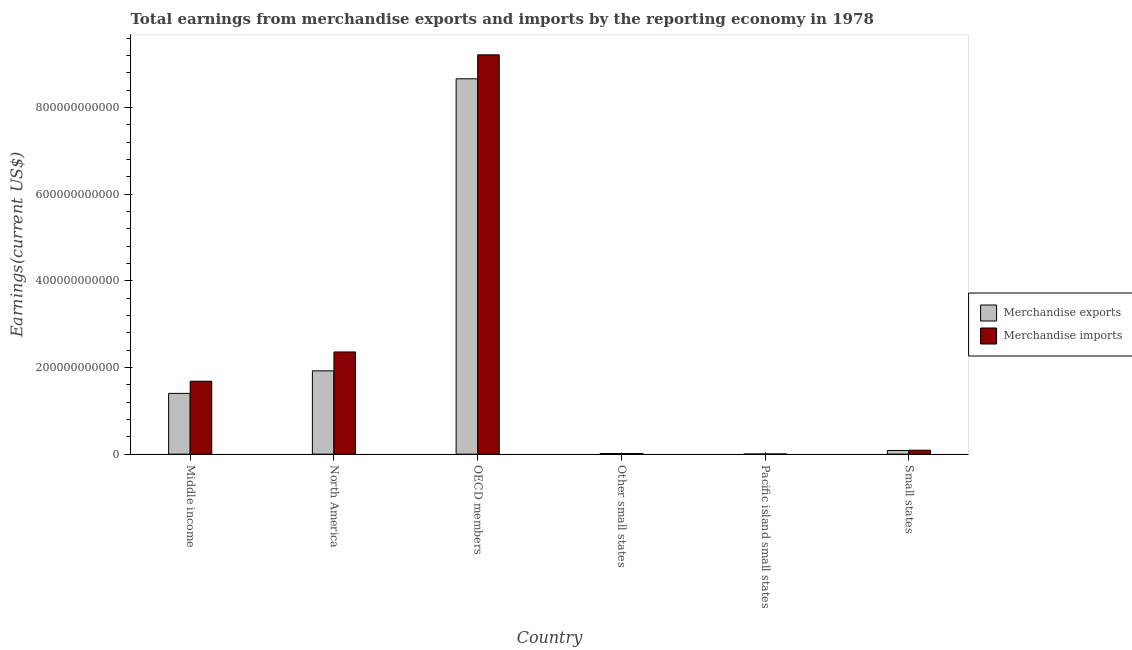How many different coloured bars are there?
Provide a short and direct response. 2. How many bars are there on the 3rd tick from the left?
Keep it short and to the point. 2. How many bars are there on the 6th tick from the right?
Your answer should be very brief. 2. What is the label of the 5th group of bars from the left?
Provide a short and direct response. Pacific island small states. In how many cases, is the number of bars for a given country not equal to the number of legend labels?
Give a very brief answer. 0. What is the earnings from merchandise imports in OECD members?
Your response must be concise. 9.21e+11. Across all countries, what is the maximum earnings from merchandise imports?
Keep it short and to the point. 9.21e+11. Across all countries, what is the minimum earnings from merchandise imports?
Your response must be concise. 4.48e+08. In which country was the earnings from merchandise imports minimum?
Provide a succinct answer. Pacific island small states. What is the total earnings from merchandise exports in the graph?
Your answer should be compact. 1.21e+12. What is the difference between the earnings from merchandise exports in North America and that in Small states?
Offer a terse response. 1.84e+11. What is the difference between the earnings from merchandise imports in OECD members and the earnings from merchandise exports in Middle income?
Ensure brevity in your answer.  7.81e+11. What is the average earnings from merchandise exports per country?
Offer a terse response. 2.02e+11. What is the difference between the earnings from merchandise exports and earnings from merchandise imports in OECD members?
Provide a succinct answer. -5.52e+1. In how many countries, is the earnings from merchandise exports greater than 880000000000 US$?
Offer a terse response. 0. What is the ratio of the earnings from merchandise exports in Other small states to that in Small states?
Give a very brief answer. 0.18. Is the earnings from merchandise exports in OECD members less than that in Small states?
Make the answer very short. No. What is the difference between the highest and the second highest earnings from merchandise exports?
Give a very brief answer. 6.74e+11. What is the difference between the highest and the lowest earnings from merchandise imports?
Provide a short and direct response. 9.21e+11. Is the sum of the earnings from merchandise exports in OECD members and Small states greater than the maximum earnings from merchandise imports across all countries?
Make the answer very short. No. What does the 1st bar from the left in Middle income represents?
Ensure brevity in your answer.  Merchandise exports. What does the 2nd bar from the right in North America represents?
Your answer should be compact. Merchandise exports. How many bars are there?
Provide a short and direct response. 12. Are all the bars in the graph horizontal?
Your response must be concise. No. How many countries are there in the graph?
Provide a succinct answer. 6. What is the difference between two consecutive major ticks on the Y-axis?
Ensure brevity in your answer.  2.00e+11. Does the graph contain grids?
Your answer should be compact. No. How many legend labels are there?
Give a very brief answer. 2. How are the legend labels stacked?
Keep it short and to the point. Vertical. What is the title of the graph?
Your answer should be very brief. Total earnings from merchandise exports and imports by the reporting economy in 1978. Does "constant 2005 US$" appear as one of the legend labels in the graph?
Offer a very short reply. No. What is the label or title of the Y-axis?
Make the answer very short. Earnings(current US$). What is the Earnings(current US$) of Merchandise exports in Middle income?
Your answer should be compact. 1.40e+11. What is the Earnings(current US$) of Merchandise imports in Middle income?
Provide a short and direct response. 1.68e+11. What is the Earnings(current US$) in Merchandise exports in North America?
Give a very brief answer. 1.92e+11. What is the Earnings(current US$) of Merchandise imports in North America?
Ensure brevity in your answer.  2.36e+11. What is the Earnings(current US$) in Merchandise exports in OECD members?
Provide a succinct answer. 8.66e+11. What is the Earnings(current US$) of Merchandise imports in OECD members?
Make the answer very short. 9.21e+11. What is the Earnings(current US$) of Merchandise exports in Other small states?
Your answer should be compact. 1.50e+09. What is the Earnings(current US$) of Merchandise imports in Other small states?
Provide a short and direct response. 1.39e+09. What is the Earnings(current US$) of Merchandise exports in Pacific island small states?
Offer a terse response. 3.00e+08. What is the Earnings(current US$) of Merchandise imports in Pacific island small states?
Ensure brevity in your answer.  4.48e+08. What is the Earnings(current US$) in Merchandise exports in Small states?
Make the answer very short. 8.58e+09. What is the Earnings(current US$) of Merchandise imports in Small states?
Ensure brevity in your answer.  9.13e+09. Across all countries, what is the maximum Earnings(current US$) of Merchandise exports?
Provide a short and direct response. 8.66e+11. Across all countries, what is the maximum Earnings(current US$) of Merchandise imports?
Your answer should be very brief. 9.21e+11. Across all countries, what is the minimum Earnings(current US$) of Merchandise exports?
Offer a terse response. 3.00e+08. Across all countries, what is the minimum Earnings(current US$) in Merchandise imports?
Keep it short and to the point. 4.48e+08. What is the total Earnings(current US$) of Merchandise exports in the graph?
Your answer should be compact. 1.21e+12. What is the total Earnings(current US$) of Merchandise imports in the graph?
Provide a short and direct response. 1.34e+12. What is the difference between the Earnings(current US$) in Merchandise exports in Middle income and that in North America?
Ensure brevity in your answer.  -5.20e+1. What is the difference between the Earnings(current US$) in Merchandise imports in Middle income and that in North America?
Your answer should be compact. -6.76e+1. What is the difference between the Earnings(current US$) in Merchandise exports in Middle income and that in OECD members?
Provide a short and direct response. -7.26e+11. What is the difference between the Earnings(current US$) in Merchandise imports in Middle income and that in OECD members?
Offer a terse response. -7.53e+11. What is the difference between the Earnings(current US$) in Merchandise exports in Middle income and that in Other small states?
Your answer should be compact. 1.39e+11. What is the difference between the Earnings(current US$) in Merchandise imports in Middle income and that in Other small states?
Provide a short and direct response. 1.67e+11. What is the difference between the Earnings(current US$) of Merchandise exports in Middle income and that in Pacific island small states?
Provide a succinct answer. 1.40e+11. What is the difference between the Earnings(current US$) in Merchandise imports in Middle income and that in Pacific island small states?
Give a very brief answer. 1.68e+11. What is the difference between the Earnings(current US$) of Merchandise exports in Middle income and that in Small states?
Offer a very short reply. 1.32e+11. What is the difference between the Earnings(current US$) in Merchandise imports in Middle income and that in Small states?
Your answer should be very brief. 1.59e+11. What is the difference between the Earnings(current US$) in Merchandise exports in North America and that in OECD members?
Your response must be concise. -6.74e+11. What is the difference between the Earnings(current US$) in Merchandise imports in North America and that in OECD members?
Your answer should be compact. -6.86e+11. What is the difference between the Earnings(current US$) of Merchandise exports in North America and that in Other small states?
Offer a very short reply. 1.91e+11. What is the difference between the Earnings(current US$) of Merchandise imports in North America and that in Other small states?
Provide a short and direct response. 2.34e+11. What is the difference between the Earnings(current US$) in Merchandise exports in North America and that in Pacific island small states?
Provide a short and direct response. 1.92e+11. What is the difference between the Earnings(current US$) in Merchandise imports in North America and that in Pacific island small states?
Ensure brevity in your answer.  2.35e+11. What is the difference between the Earnings(current US$) in Merchandise exports in North America and that in Small states?
Provide a succinct answer. 1.84e+11. What is the difference between the Earnings(current US$) of Merchandise imports in North America and that in Small states?
Ensure brevity in your answer.  2.27e+11. What is the difference between the Earnings(current US$) of Merchandise exports in OECD members and that in Other small states?
Ensure brevity in your answer.  8.65e+11. What is the difference between the Earnings(current US$) of Merchandise imports in OECD members and that in Other small states?
Provide a short and direct response. 9.20e+11. What is the difference between the Earnings(current US$) of Merchandise exports in OECD members and that in Pacific island small states?
Offer a terse response. 8.66e+11. What is the difference between the Earnings(current US$) of Merchandise imports in OECD members and that in Pacific island small states?
Your response must be concise. 9.21e+11. What is the difference between the Earnings(current US$) of Merchandise exports in OECD members and that in Small states?
Keep it short and to the point. 8.58e+11. What is the difference between the Earnings(current US$) of Merchandise imports in OECD members and that in Small states?
Your response must be concise. 9.12e+11. What is the difference between the Earnings(current US$) of Merchandise exports in Other small states and that in Pacific island small states?
Keep it short and to the point. 1.20e+09. What is the difference between the Earnings(current US$) of Merchandise imports in Other small states and that in Pacific island small states?
Offer a terse response. 9.38e+08. What is the difference between the Earnings(current US$) in Merchandise exports in Other small states and that in Small states?
Ensure brevity in your answer.  -7.07e+09. What is the difference between the Earnings(current US$) of Merchandise imports in Other small states and that in Small states?
Provide a short and direct response. -7.74e+09. What is the difference between the Earnings(current US$) of Merchandise exports in Pacific island small states and that in Small states?
Offer a very short reply. -8.28e+09. What is the difference between the Earnings(current US$) of Merchandise imports in Pacific island small states and that in Small states?
Provide a short and direct response. -8.68e+09. What is the difference between the Earnings(current US$) of Merchandise exports in Middle income and the Earnings(current US$) of Merchandise imports in North America?
Your answer should be very brief. -9.56e+1. What is the difference between the Earnings(current US$) of Merchandise exports in Middle income and the Earnings(current US$) of Merchandise imports in OECD members?
Provide a succinct answer. -7.81e+11. What is the difference between the Earnings(current US$) of Merchandise exports in Middle income and the Earnings(current US$) of Merchandise imports in Other small states?
Your answer should be very brief. 1.39e+11. What is the difference between the Earnings(current US$) in Merchandise exports in Middle income and the Earnings(current US$) in Merchandise imports in Pacific island small states?
Offer a terse response. 1.40e+11. What is the difference between the Earnings(current US$) in Merchandise exports in Middle income and the Earnings(current US$) in Merchandise imports in Small states?
Your answer should be very brief. 1.31e+11. What is the difference between the Earnings(current US$) of Merchandise exports in North America and the Earnings(current US$) of Merchandise imports in OECD members?
Make the answer very short. -7.29e+11. What is the difference between the Earnings(current US$) of Merchandise exports in North America and the Earnings(current US$) of Merchandise imports in Other small states?
Provide a succinct answer. 1.91e+11. What is the difference between the Earnings(current US$) of Merchandise exports in North America and the Earnings(current US$) of Merchandise imports in Pacific island small states?
Offer a terse response. 1.92e+11. What is the difference between the Earnings(current US$) in Merchandise exports in North America and the Earnings(current US$) in Merchandise imports in Small states?
Offer a terse response. 1.83e+11. What is the difference between the Earnings(current US$) of Merchandise exports in OECD members and the Earnings(current US$) of Merchandise imports in Other small states?
Offer a terse response. 8.65e+11. What is the difference between the Earnings(current US$) of Merchandise exports in OECD members and the Earnings(current US$) of Merchandise imports in Pacific island small states?
Your response must be concise. 8.66e+11. What is the difference between the Earnings(current US$) of Merchandise exports in OECD members and the Earnings(current US$) of Merchandise imports in Small states?
Make the answer very short. 8.57e+11. What is the difference between the Earnings(current US$) in Merchandise exports in Other small states and the Earnings(current US$) in Merchandise imports in Pacific island small states?
Keep it short and to the point. 1.05e+09. What is the difference between the Earnings(current US$) in Merchandise exports in Other small states and the Earnings(current US$) in Merchandise imports in Small states?
Provide a short and direct response. -7.62e+09. What is the difference between the Earnings(current US$) in Merchandise exports in Pacific island small states and the Earnings(current US$) in Merchandise imports in Small states?
Offer a terse response. -8.83e+09. What is the average Earnings(current US$) in Merchandise exports per country?
Keep it short and to the point. 2.02e+11. What is the average Earnings(current US$) of Merchandise imports per country?
Provide a short and direct response. 2.23e+11. What is the difference between the Earnings(current US$) of Merchandise exports and Earnings(current US$) of Merchandise imports in Middle income?
Keep it short and to the point. -2.80e+1. What is the difference between the Earnings(current US$) of Merchandise exports and Earnings(current US$) of Merchandise imports in North America?
Your answer should be very brief. -4.36e+1. What is the difference between the Earnings(current US$) in Merchandise exports and Earnings(current US$) in Merchandise imports in OECD members?
Keep it short and to the point. -5.52e+1. What is the difference between the Earnings(current US$) of Merchandise exports and Earnings(current US$) of Merchandise imports in Other small states?
Provide a short and direct response. 1.16e+08. What is the difference between the Earnings(current US$) in Merchandise exports and Earnings(current US$) in Merchandise imports in Pacific island small states?
Your answer should be compact. -1.48e+08. What is the difference between the Earnings(current US$) of Merchandise exports and Earnings(current US$) of Merchandise imports in Small states?
Give a very brief answer. -5.49e+08. What is the ratio of the Earnings(current US$) in Merchandise exports in Middle income to that in North America?
Your answer should be very brief. 0.73. What is the ratio of the Earnings(current US$) of Merchandise imports in Middle income to that in North America?
Keep it short and to the point. 0.71. What is the ratio of the Earnings(current US$) of Merchandise exports in Middle income to that in OECD members?
Provide a succinct answer. 0.16. What is the ratio of the Earnings(current US$) in Merchandise imports in Middle income to that in OECD members?
Make the answer very short. 0.18. What is the ratio of the Earnings(current US$) of Merchandise exports in Middle income to that in Other small states?
Provide a short and direct response. 93.39. What is the ratio of the Earnings(current US$) in Merchandise imports in Middle income to that in Other small states?
Keep it short and to the point. 121.4. What is the ratio of the Earnings(current US$) of Merchandise exports in Middle income to that in Pacific island small states?
Provide a succinct answer. 467.15. What is the ratio of the Earnings(current US$) of Merchandise imports in Middle income to that in Pacific island small states?
Give a very brief answer. 375.24. What is the ratio of the Earnings(current US$) of Merchandise exports in Middle income to that in Small states?
Offer a terse response. 16.35. What is the ratio of the Earnings(current US$) in Merchandise imports in Middle income to that in Small states?
Keep it short and to the point. 18.44. What is the ratio of the Earnings(current US$) of Merchandise exports in North America to that in OECD members?
Offer a very short reply. 0.22. What is the ratio of the Earnings(current US$) of Merchandise imports in North America to that in OECD members?
Provide a short and direct response. 0.26. What is the ratio of the Earnings(current US$) in Merchandise exports in North America to that in Other small states?
Your answer should be very brief. 128.04. What is the ratio of the Earnings(current US$) of Merchandise imports in North America to that in Other small states?
Provide a succinct answer. 170.14. What is the ratio of the Earnings(current US$) of Merchandise exports in North America to that in Pacific island small states?
Ensure brevity in your answer.  640.45. What is the ratio of the Earnings(current US$) of Merchandise imports in North America to that in Pacific island small states?
Ensure brevity in your answer.  525.91. What is the ratio of the Earnings(current US$) in Merchandise exports in North America to that in Small states?
Offer a very short reply. 22.42. What is the ratio of the Earnings(current US$) of Merchandise imports in North America to that in Small states?
Your response must be concise. 25.84. What is the ratio of the Earnings(current US$) in Merchandise exports in OECD members to that in Other small states?
Keep it short and to the point. 576.8. What is the ratio of the Earnings(current US$) of Merchandise imports in OECD members to that in Other small states?
Offer a terse response. 664.79. What is the ratio of the Earnings(current US$) in Merchandise exports in OECD members to that in Pacific island small states?
Ensure brevity in your answer.  2885.18. What is the ratio of the Earnings(current US$) in Merchandise imports in OECD members to that in Pacific island small states?
Offer a very short reply. 2054.85. What is the ratio of the Earnings(current US$) of Merchandise exports in OECD members to that in Small states?
Provide a succinct answer. 101. What is the ratio of the Earnings(current US$) in Merchandise imports in OECD members to that in Small states?
Provide a succinct answer. 100.98. What is the ratio of the Earnings(current US$) of Merchandise exports in Other small states to that in Pacific island small states?
Give a very brief answer. 5. What is the ratio of the Earnings(current US$) in Merchandise imports in Other small states to that in Pacific island small states?
Offer a very short reply. 3.09. What is the ratio of the Earnings(current US$) of Merchandise exports in Other small states to that in Small states?
Give a very brief answer. 0.18. What is the ratio of the Earnings(current US$) of Merchandise imports in Other small states to that in Small states?
Give a very brief answer. 0.15. What is the ratio of the Earnings(current US$) of Merchandise exports in Pacific island small states to that in Small states?
Provide a succinct answer. 0.04. What is the ratio of the Earnings(current US$) of Merchandise imports in Pacific island small states to that in Small states?
Give a very brief answer. 0.05. What is the difference between the highest and the second highest Earnings(current US$) in Merchandise exports?
Offer a terse response. 6.74e+11. What is the difference between the highest and the second highest Earnings(current US$) of Merchandise imports?
Your answer should be compact. 6.86e+11. What is the difference between the highest and the lowest Earnings(current US$) of Merchandise exports?
Your answer should be compact. 8.66e+11. What is the difference between the highest and the lowest Earnings(current US$) in Merchandise imports?
Offer a terse response. 9.21e+11. 